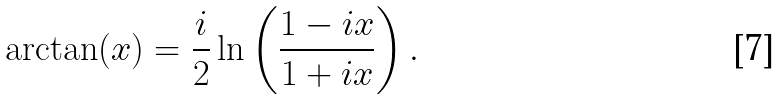Convert formula to latex. <formula><loc_0><loc_0><loc_500><loc_500>\arctan ( x ) = \frac { i } { 2 } \ln \left ( \frac { 1 - i x } { 1 + i x } \right ) .</formula> 